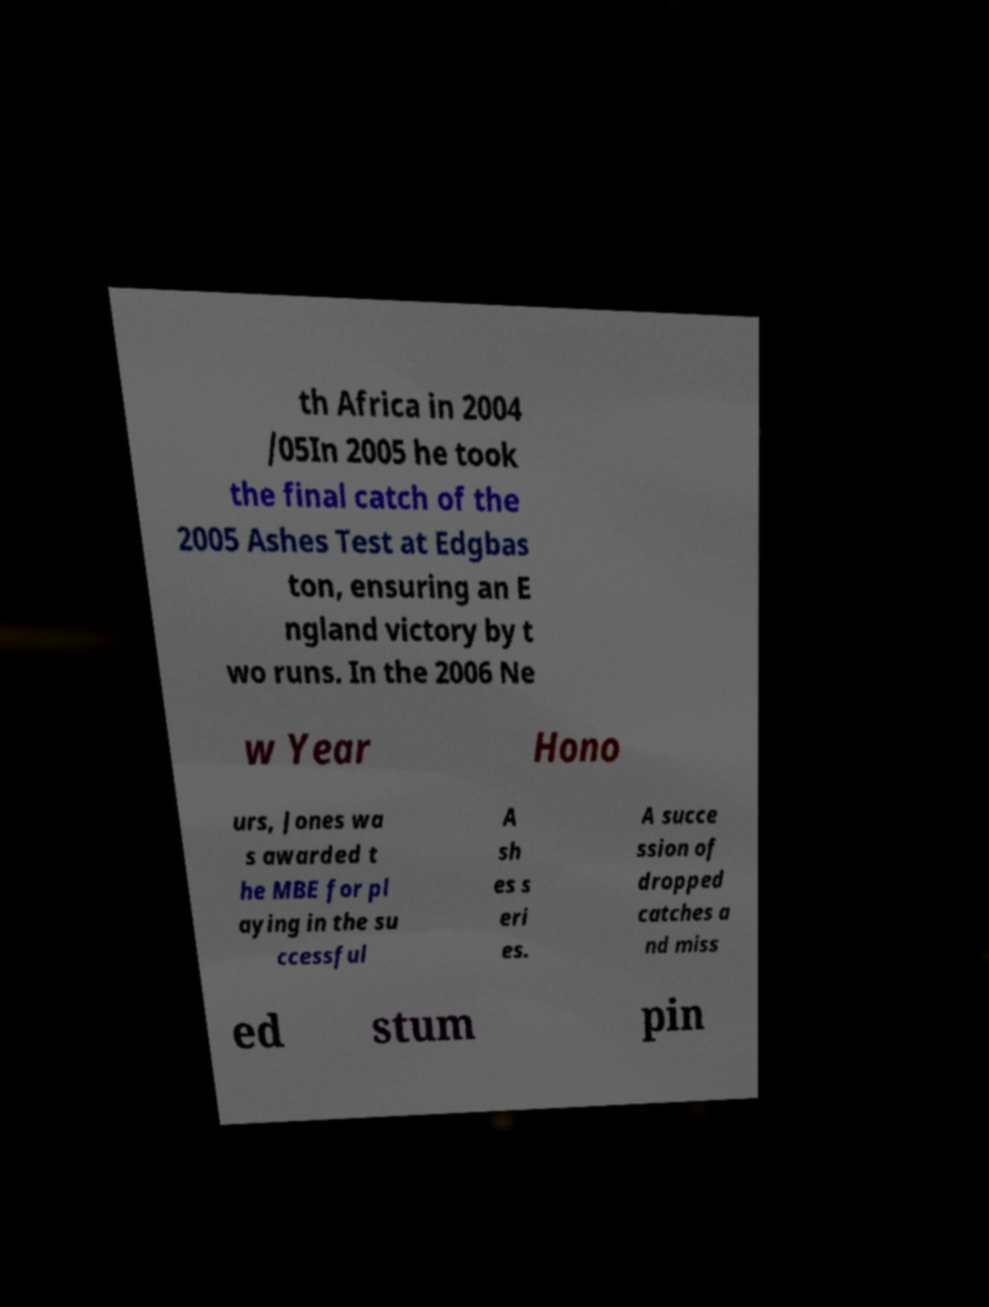Please identify and transcribe the text found in this image. th Africa in 2004 /05In 2005 he took the final catch of the 2005 Ashes Test at Edgbas ton, ensuring an E ngland victory by t wo runs. In the 2006 Ne w Year Hono urs, Jones wa s awarded t he MBE for pl aying in the su ccessful A sh es s eri es. A succe ssion of dropped catches a nd miss ed stum pin 